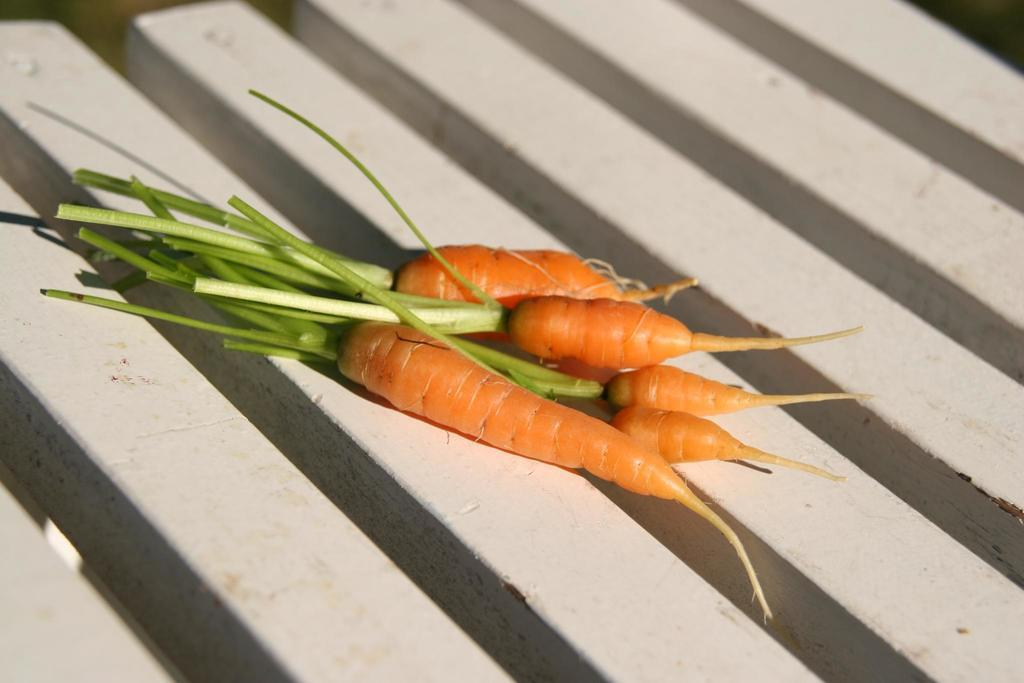What type of vegetable is present in the image? There are carrots in the image. What color is the surface on which the carrots are placed? The carrots are on a white surface. What color is the background of the image? The background of the image is black. What type of glove can be seen in the image? There is no glove present in the image. Is there any snow visible in the image? There is no snow present in the image. 